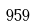<formula> <loc_0><loc_0><loc_500><loc_500>9 5 9</formula> 